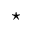Convert formula to latex. <formula><loc_0><loc_0><loc_500><loc_500>^ { * }</formula> 